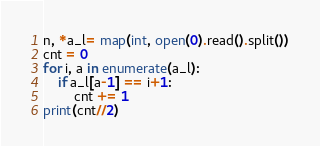<code> <loc_0><loc_0><loc_500><loc_500><_Python_>n, *a_l= map(int, open(0).read().split())
cnt = 0
for i, a in enumerate(a_l):
    if a_l[a-1] == i+1:
        cnt += 1
print(cnt//2)</code> 